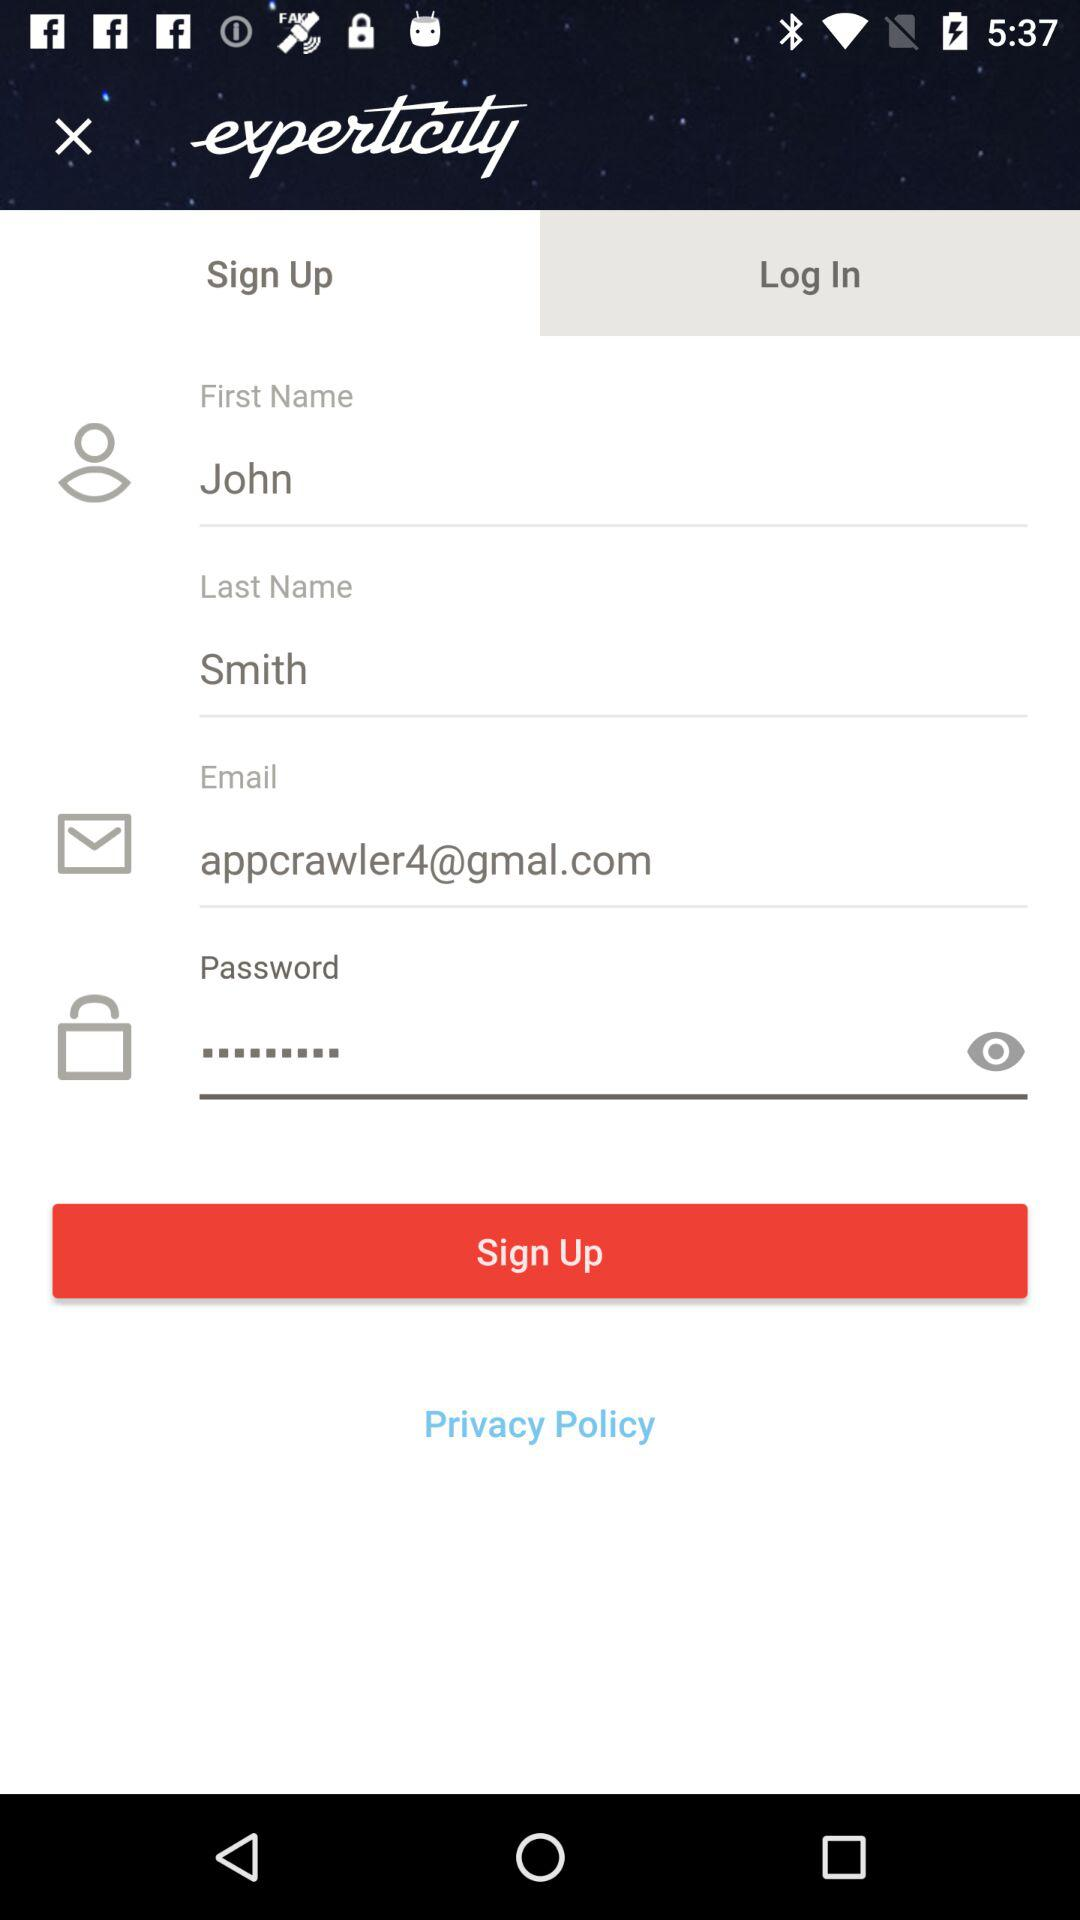What is the first name? The first name is John. 